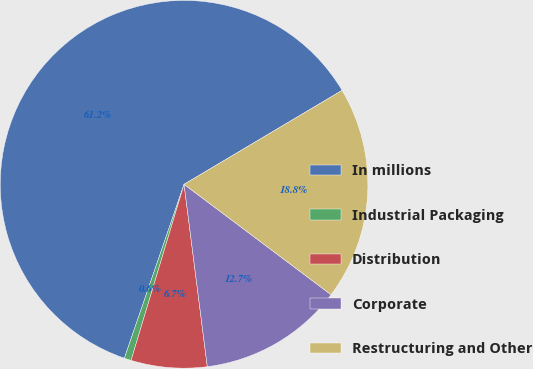<chart> <loc_0><loc_0><loc_500><loc_500><pie_chart><fcel>In millions<fcel>Industrial Packaging<fcel>Distribution<fcel>Corporate<fcel>Restructuring and Other<nl><fcel>61.21%<fcel>0.61%<fcel>6.67%<fcel>12.73%<fcel>18.79%<nl></chart> 